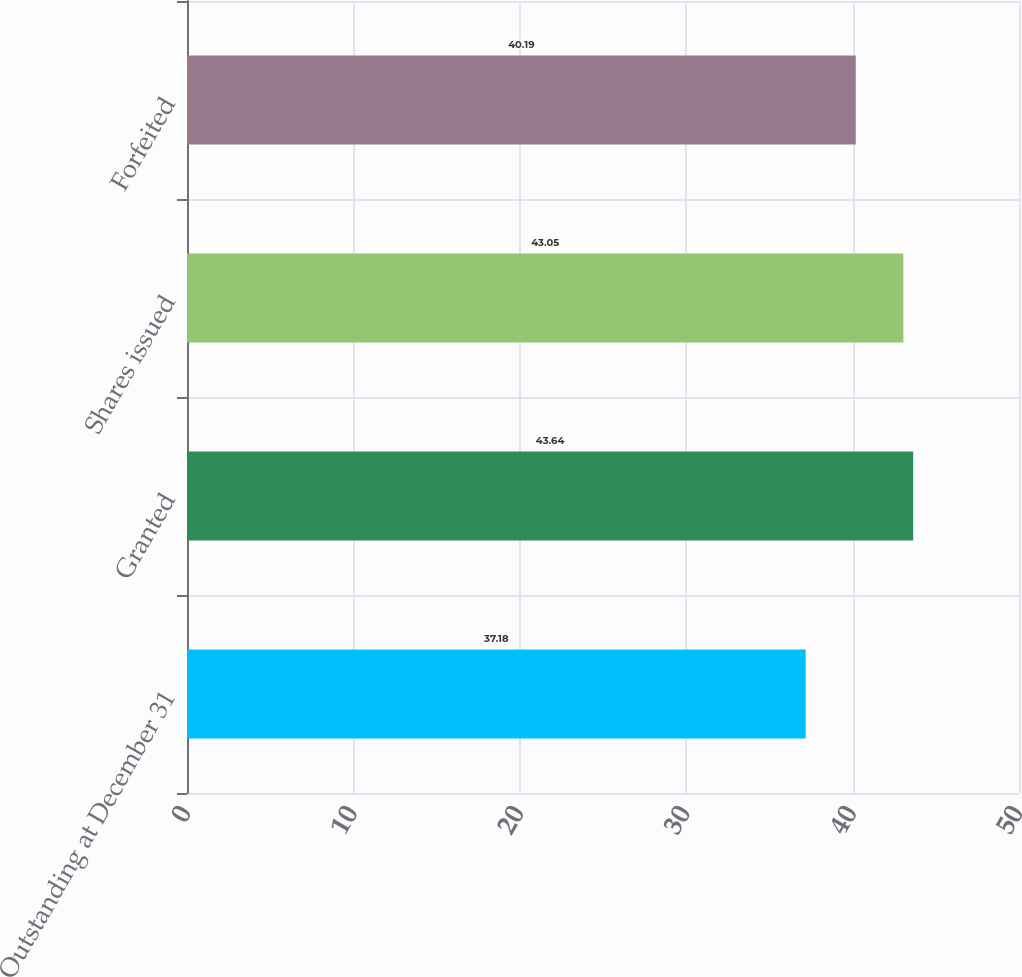Convert chart to OTSL. <chart><loc_0><loc_0><loc_500><loc_500><bar_chart><fcel>Outstanding at December 31<fcel>Granted<fcel>Shares issued<fcel>Forfeited<nl><fcel>37.18<fcel>43.64<fcel>43.05<fcel>40.19<nl></chart> 